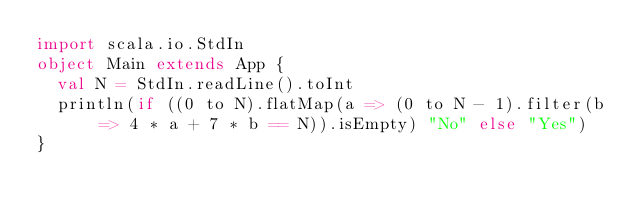<code> <loc_0><loc_0><loc_500><loc_500><_Scala_>import scala.io.StdIn
object Main extends App {
  val N = StdIn.readLine().toInt
  println(if ((0 to N).flatMap(a => (0 to N - 1).filter(b => 4 * a + 7 * b == N)).isEmpty) "No" else "Yes")
}
</code> 